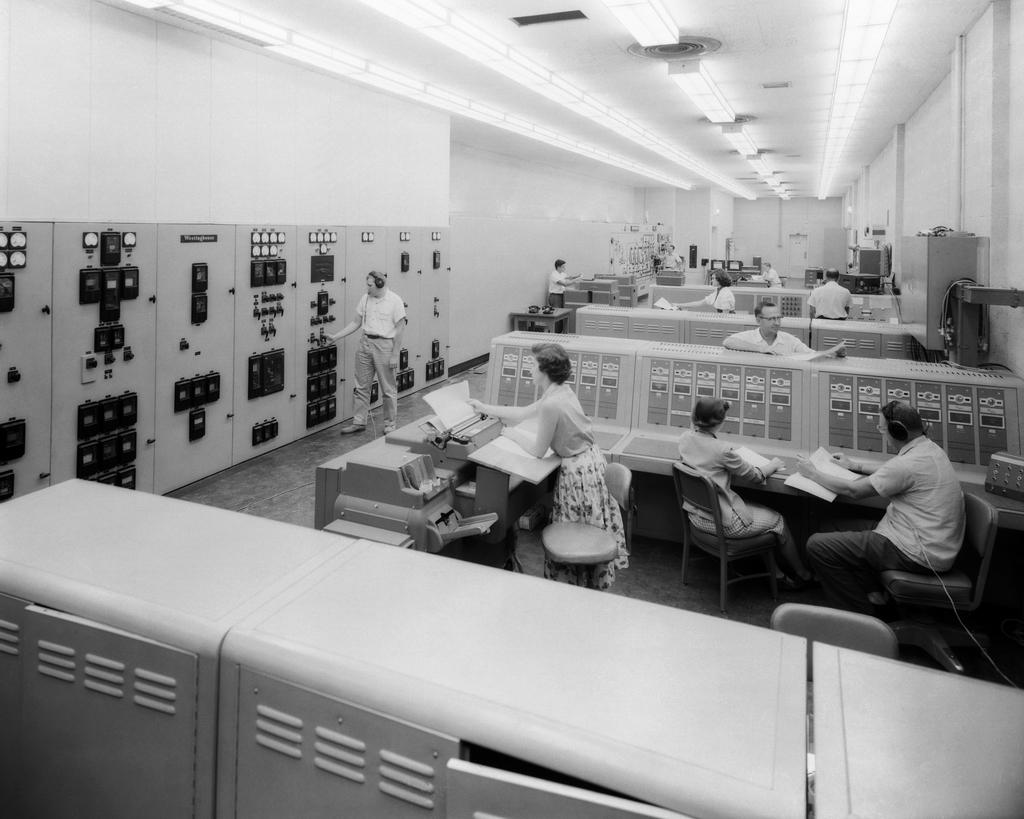What are the people in the image doing? There are persons sitting on chairs in the image. What can be seen beneath the people's feet? The floor is visible in the image. What is located behind the people in the image? There is a wall in the background of the image. What is providing illumination in the image? There are lights in the image. What is present in the image that might be used for placing objects or serving food? There is a table in the image. What type of knowledge can be gained from the branch in the image? There is no branch present in the image, so no knowledge can be gained from it. 